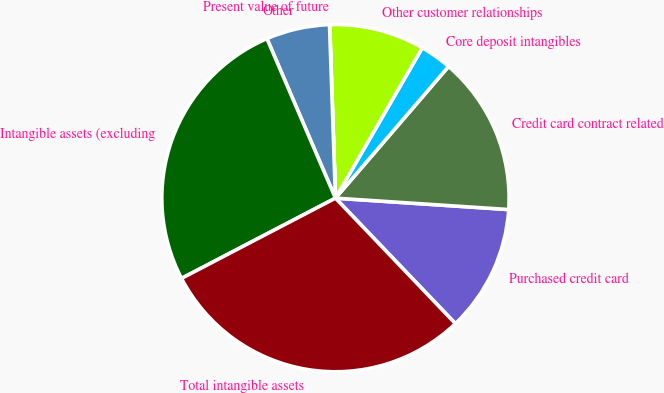<chart> <loc_0><loc_0><loc_500><loc_500><pie_chart><fcel>Purchased credit card<fcel>Credit card contract related<fcel>Core deposit intangibles<fcel>Other customer relationships<fcel>Present value of future<fcel>Other<fcel>Intangible assets (excluding<fcel>Total intangible assets<nl><fcel>11.81%<fcel>14.75%<fcel>2.96%<fcel>8.86%<fcel>0.02%<fcel>5.91%<fcel>26.19%<fcel>29.49%<nl></chart> 